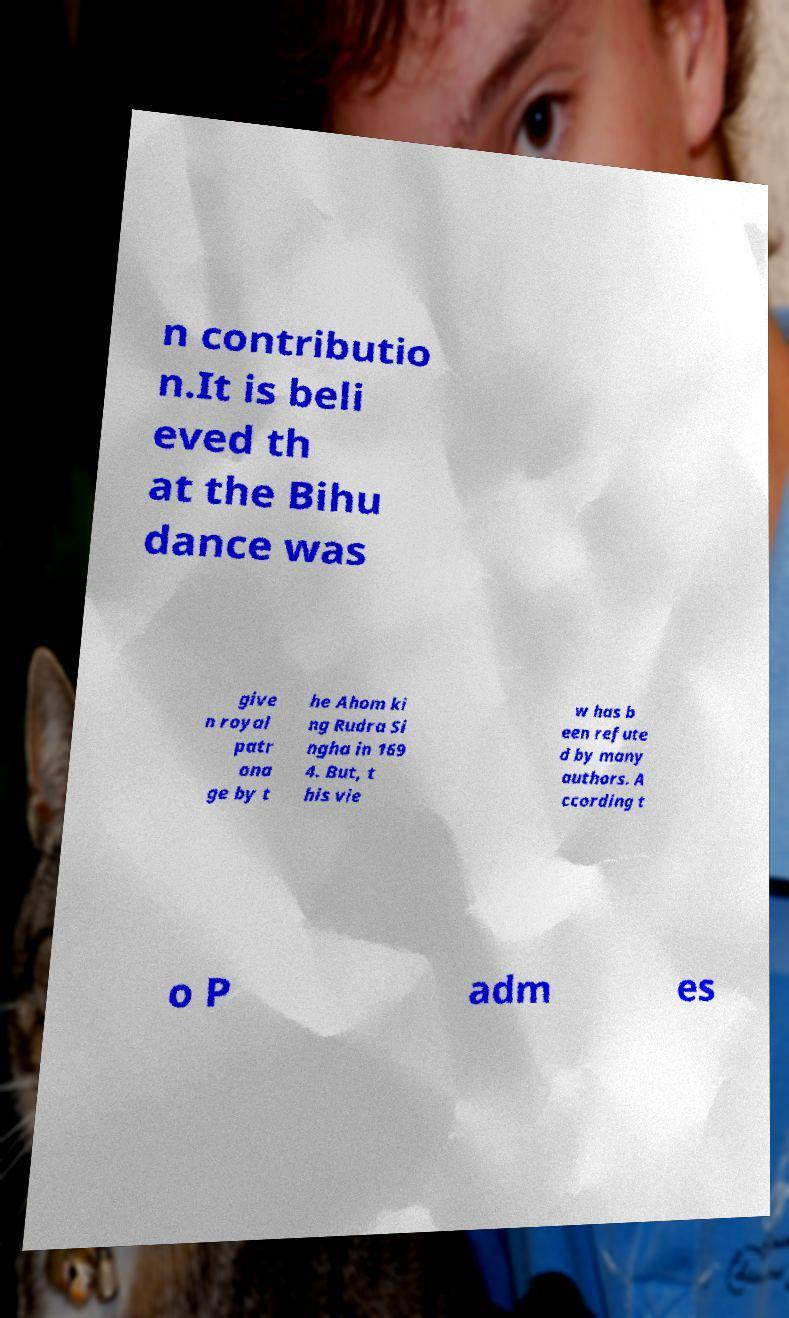I need the written content from this picture converted into text. Can you do that? n contributio n.It is beli eved th at the Bihu dance was give n royal patr ona ge by t he Ahom ki ng Rudra Si ngha in 169 4. But, t his vie w has b een refute d by many authors. A ccording t o P adm es 